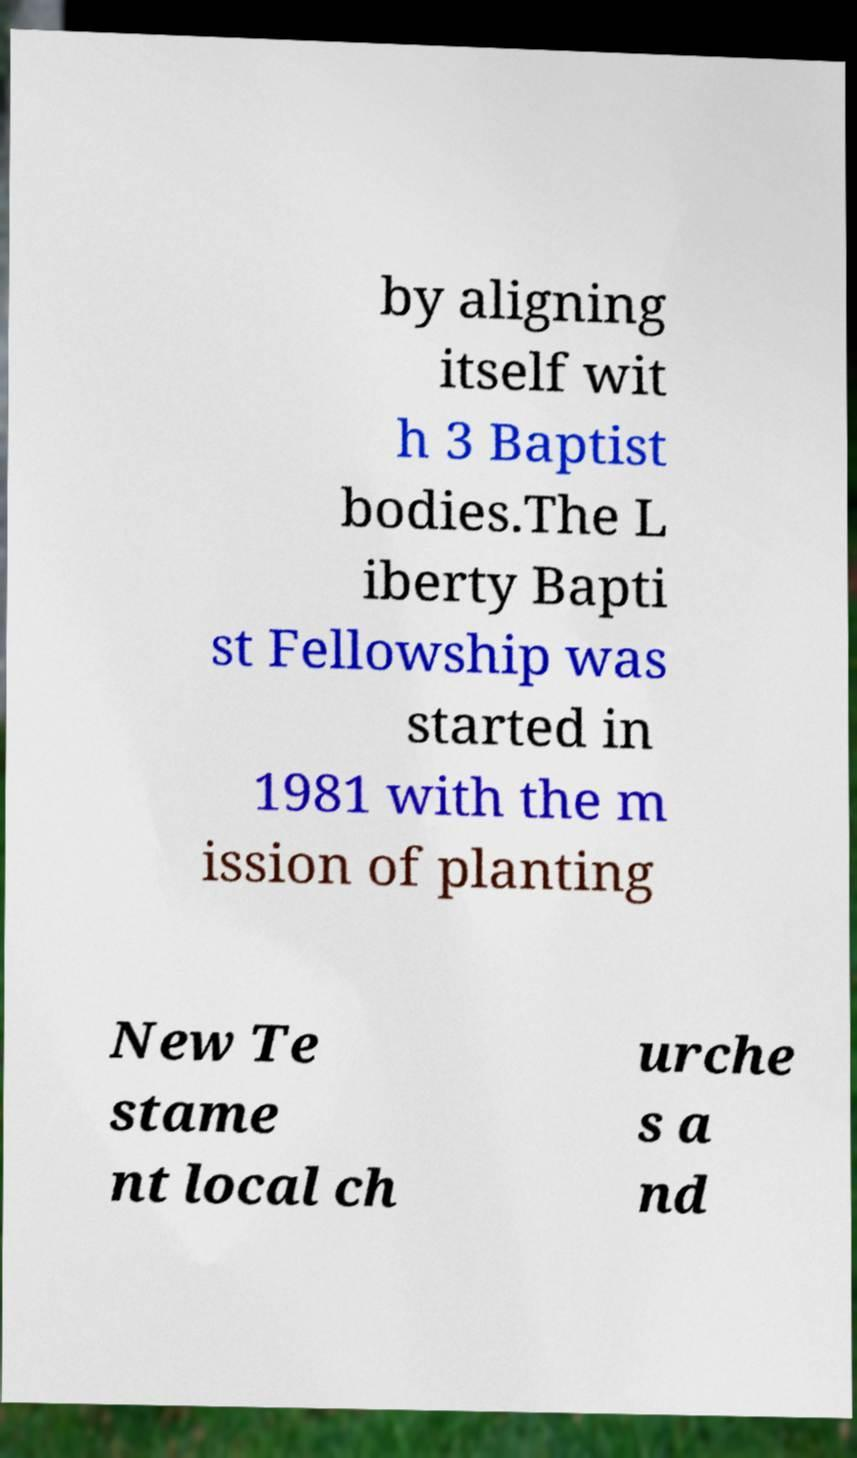What messages or text are displayed in this image? I need them in a readable, typed format. by aligning itself wit h 3 Baptist bodies.The L iberty Bapti st Fellowship was started in 1981 with the m ission of planting New Te stame nt local ch urche s a nd 